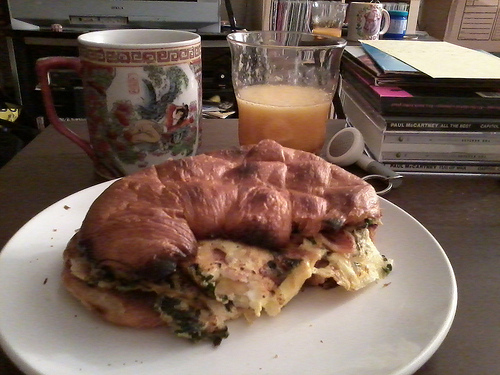<image>
Is there a bread on the eggs? Yes. Looking at the image, I can see the bread is positioned on top of the eggs, with the eggs providing support. 